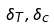<formula> <loc_0><loc_0><loc_500><loc_500>\delta _ { T } , \delta _ { c }</formula> 